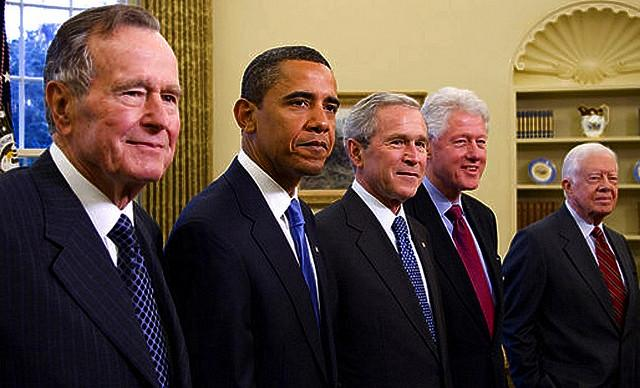Who is the second man from the left? Please explain your reasoning. barak obama. He was the current president when the photo was taken. the other men were past presidents. 